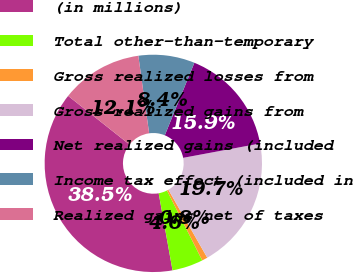<chart> <loc_0><loc_0><loc_500><loc_500><pie_chart><fcel>(in millions)<fcel>Total other-than-temporary<fcel>Gross realized losses from<fcel>Gross realized gains from<fcel>Net realized gains (included<fcel>Income tax effect (included in<fcel>Realized gains net of taxes<nl><fcel>38.49%<fcel>4.6%<fcel>0.84%<fcel>19.66%<fcel>15.9%<fcel>8.37%<fcel>12.13%<nl></chart> 